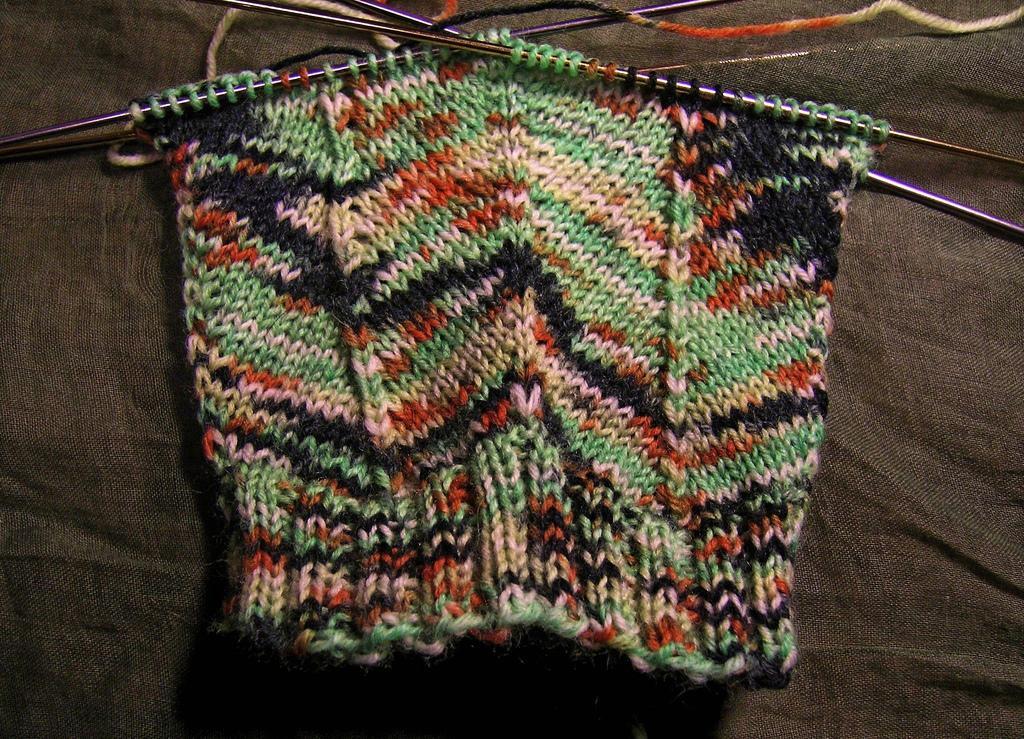Could you give a brief overview of what you see in this image? In the foreground of this image, there is a woolen cloth on the brown cloth. At the top, there are few hook needles. 